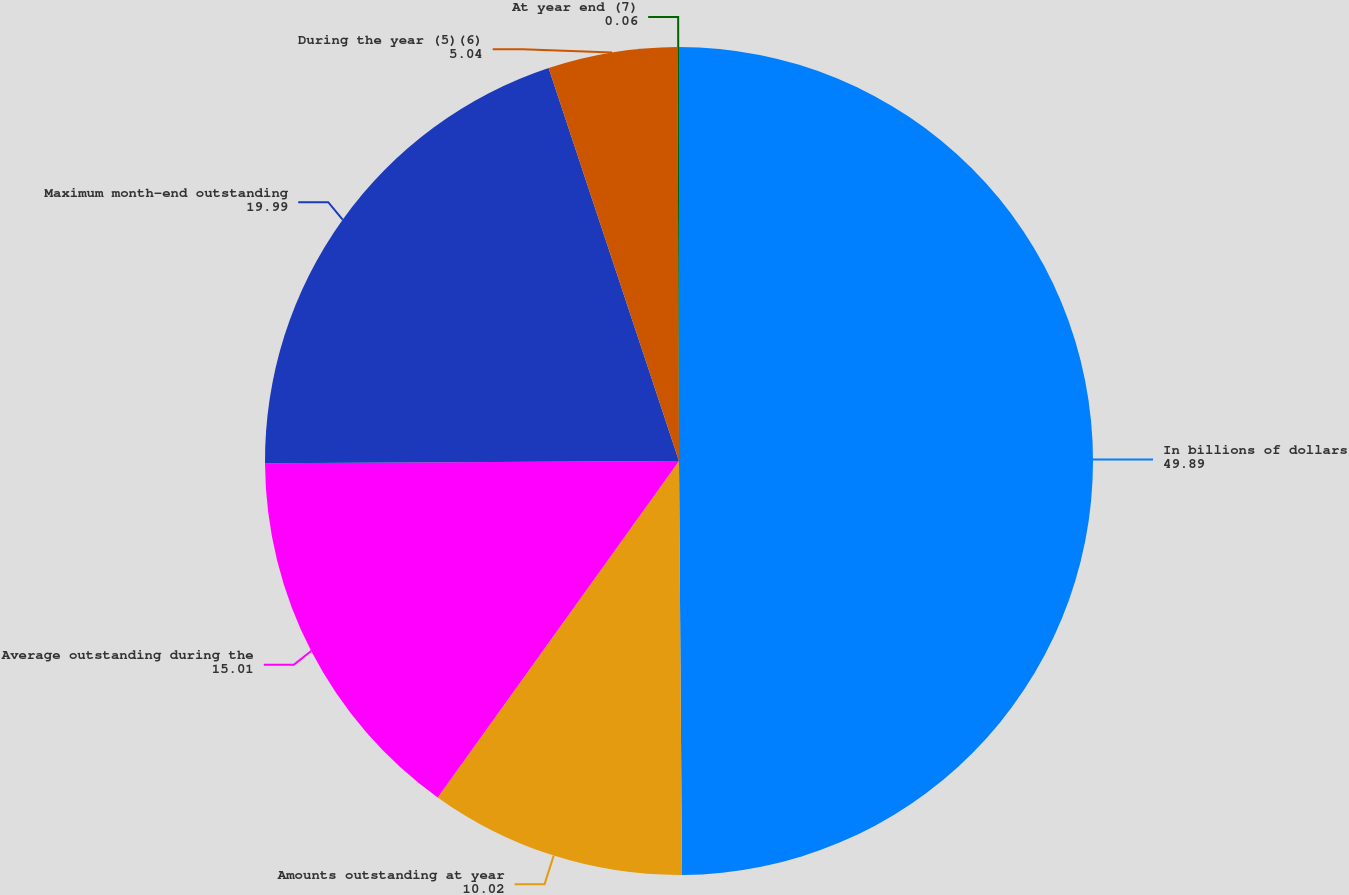Convert chart. <chart><loc_0><loc_0><loc_500><loc_500><pie_chart><fcel>In billions of dollars<fcel>Amounts outstanding at year<fcel>Average outstanding during the<fcel>Maximum month-end outstanding<fcel>During the year (5)(6)<fcel>At year end (7)<nl><fcel>49.89%<fcel>10.02%<fcel>15.01%<fcel>19.99%<fcel>5.04%<fcel>0.06%<nl></chart> 